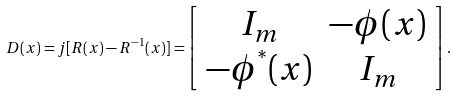<formula> <loc_0><loc_0><loc_500><loc_500>D ( x ) = j [ R ( x ) - R ^ { - 1 } ( x ) ] = \left [ \begin{array} { c c } I _ { m } & - { \phi } ( x ) \\ - { \phi } ^ { ^ { * } } ( x ) & I _ { m } \end{array} \right ] .</formula> 